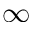<formula> <loc_0><loc_0><loc_500><loc_500>\infty</formula> 